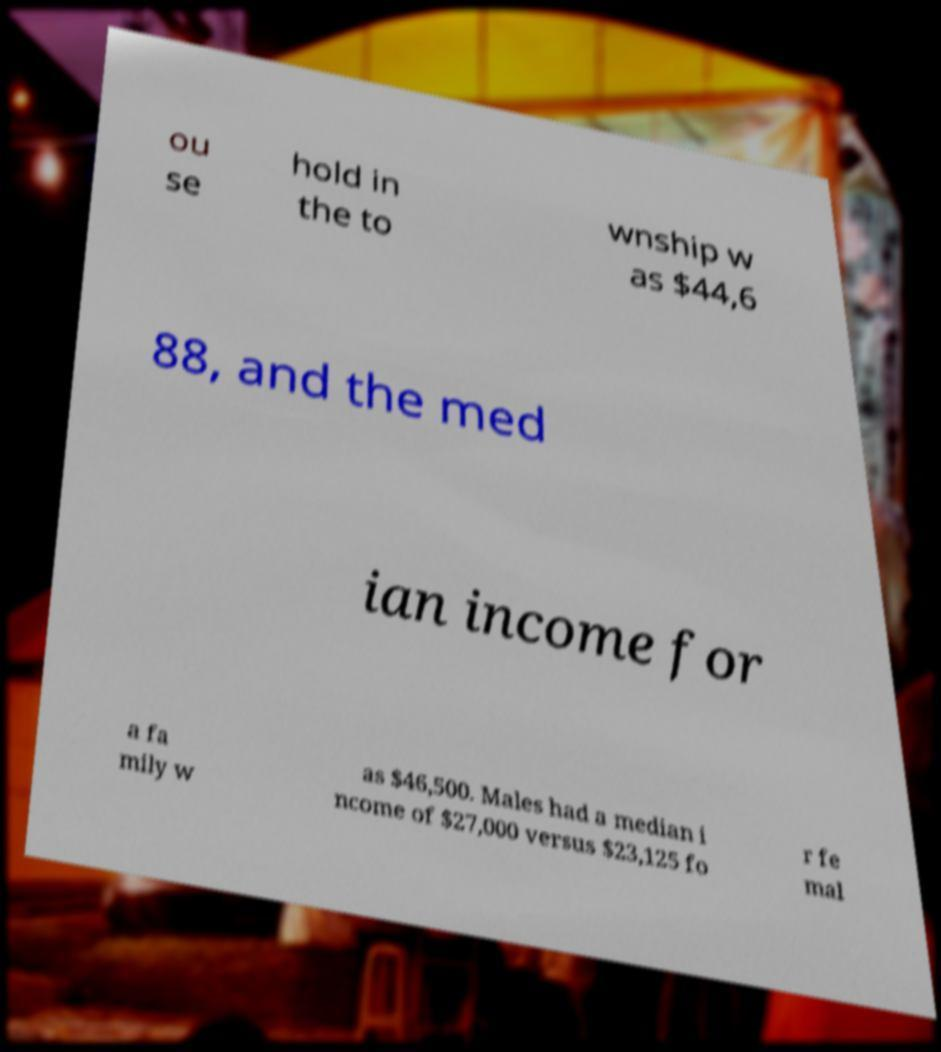Could you assist in decoding the text presented in this image and type it out clearly? ou se hold in the to wnship w as $44,6 88, and the med ian income for a fa mily w as $46,500. Males had a median i ncome of $27,000 versus $23,125 fo r fe mal 